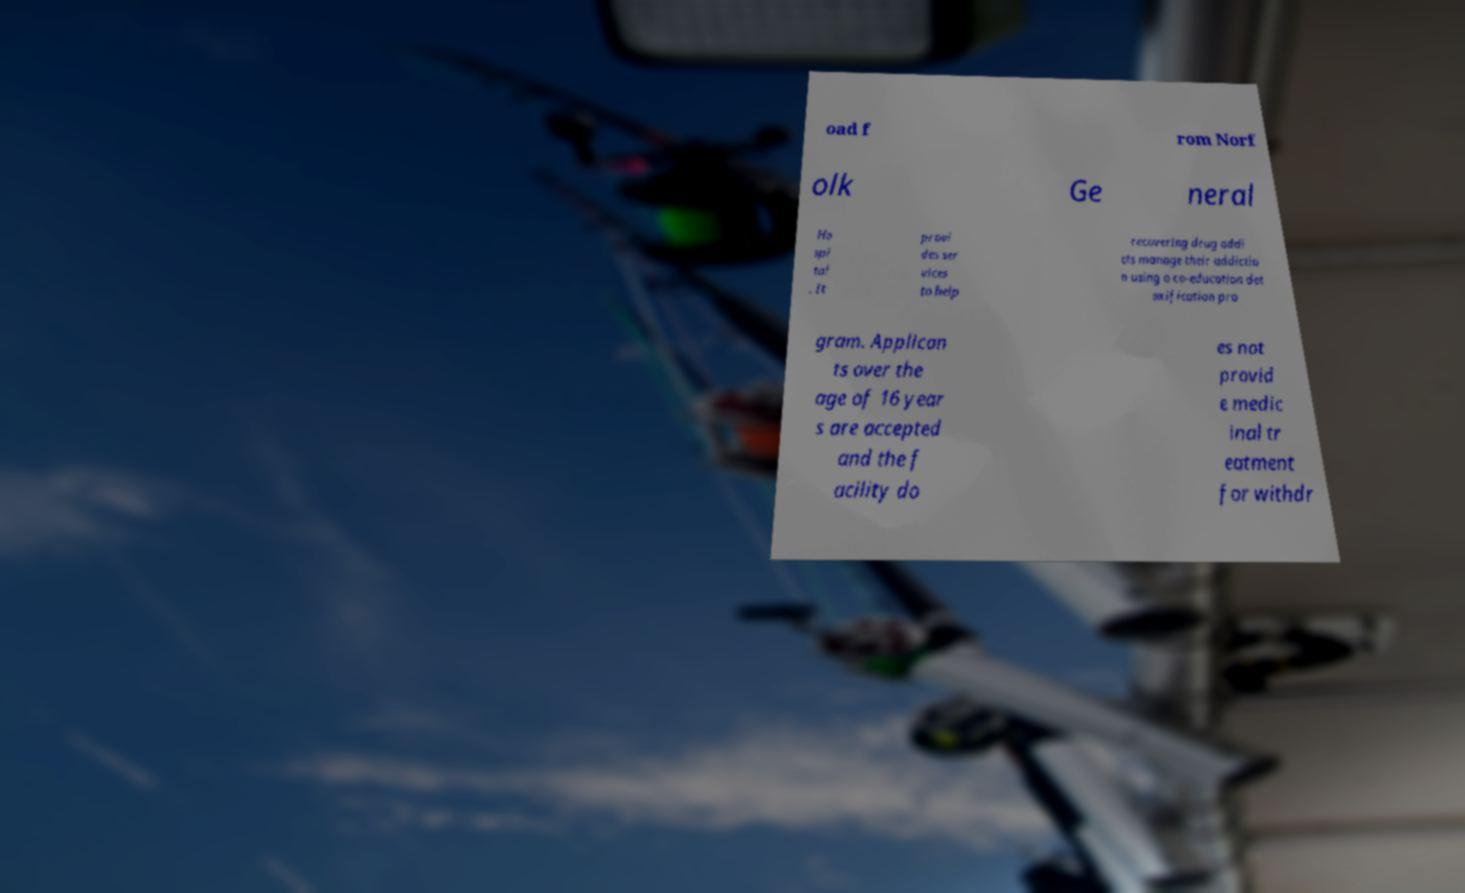What messages or text are displayed in this image? I need them in a readable, typed format. oad f rom Norf olk Ge neral Ho spi tal . It provi des ser vices to help recovering drug addi cts manage their addictio n using a co-education det oxification pro gram. Applican ts over the age of 16 year s are accepted and the f acility do es not provid e medic inal tr eatment for withdr 